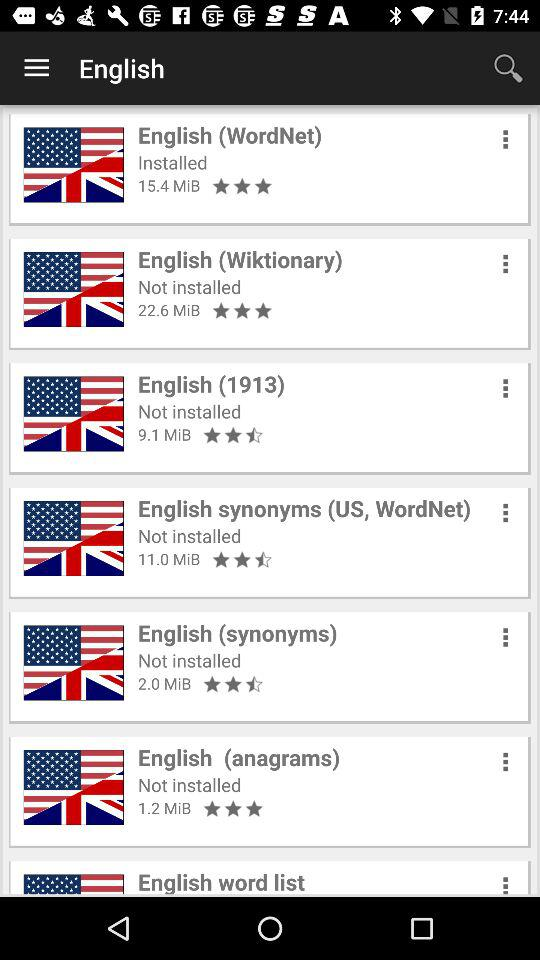What is the rating of the "English (Wiktionary)" app? The rating of the app is 3 stars. 